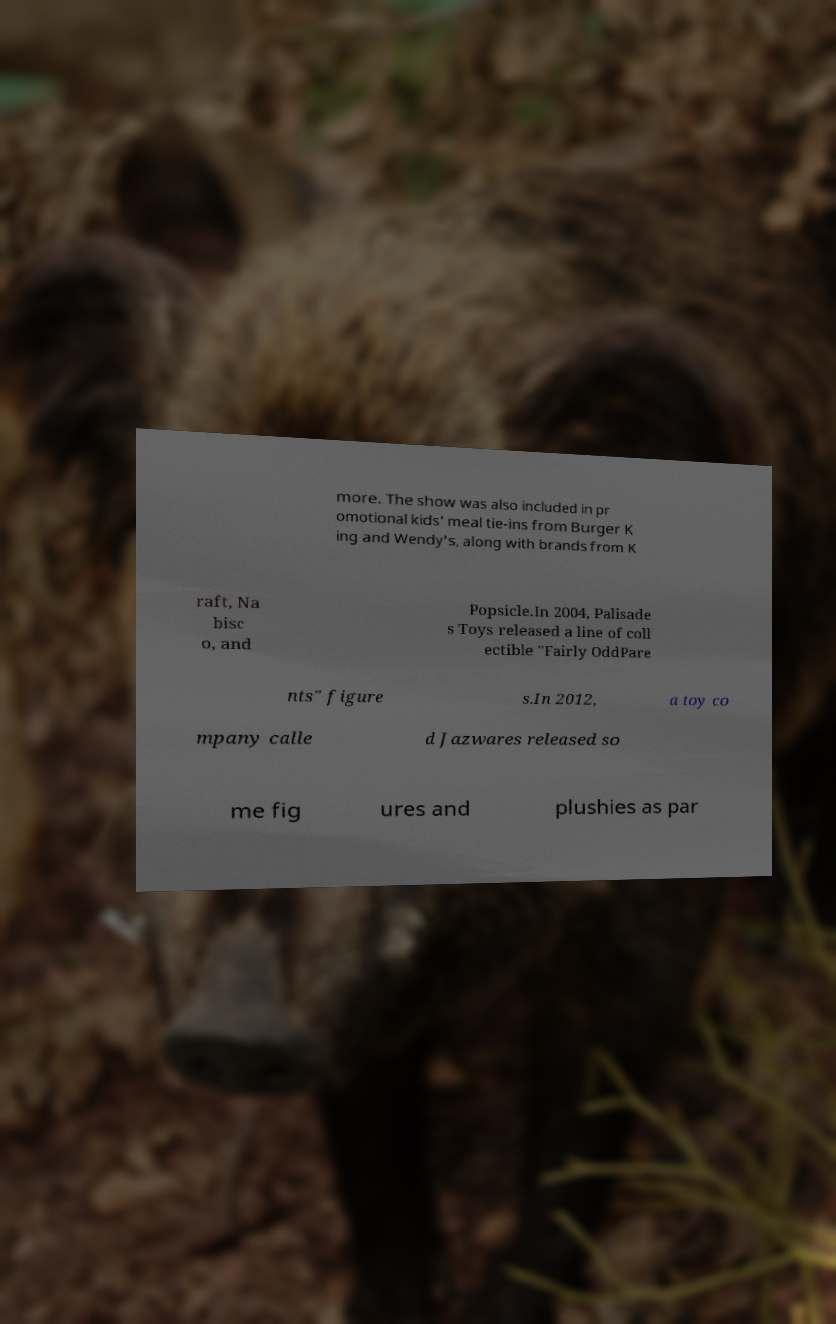For documentation purposes, I need the text within this image transcribed. Could you provide that? more. The show was also included in pr omotional kids' meal tie-ins from Burger K ing and Wendy's, along with brands from K raft, Na bisc o, and Popsicle.In 2004, Palisade s Toys released a line of coll ectible "Fairly OddPare nts" figure s.In 2012, a toy co mpany calle d Jazwares released so me fig ures and plushies as par 